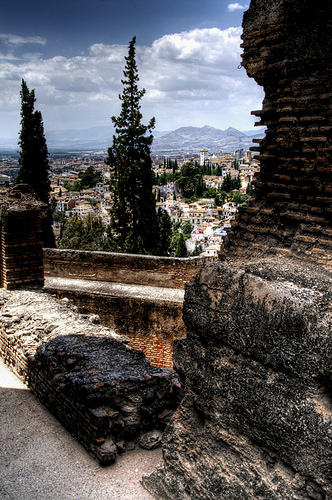<image>
Can you confirm if the tree is in front of the cloud? Yes. The tree is positioned in front of the cloud, appearing closer to the camera viewpoint. 